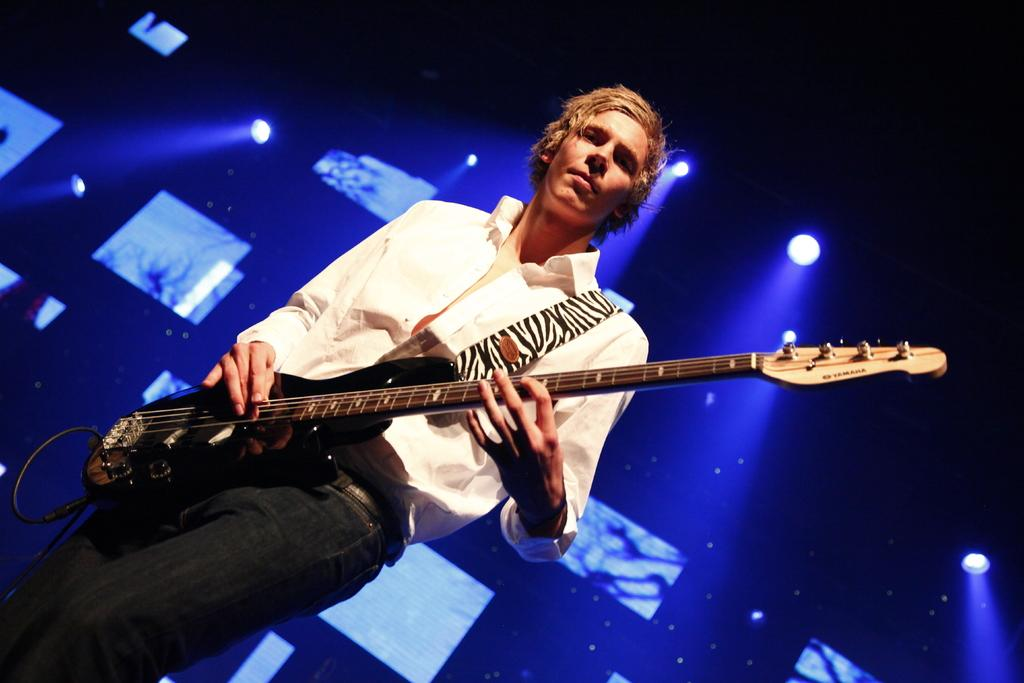What is the man in the image doing? The man is standing and playing a guitar. Can you describe the background of the image? There is a screen and focus lights in the background of the image. How does the man solve the riddle in the image? There is no riddle present in the image, so it cannot be solved. 